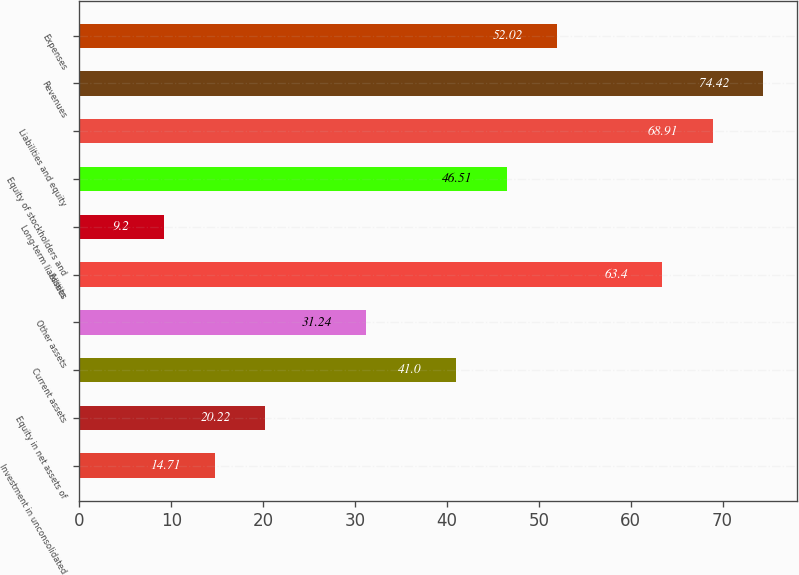Convert chart to OTSL. <chart><loc_0><loc_0><loc_500><loc_500><bar_chart><fcel>Investment in unconsolidated<fcel>Equity in net assets of<fcel>Current assets<fcel>Other assets<fcel>Assets<fcel>Long-term liabilities<fcel>Equity of stockholders and<fcel>Liabilities and equity<fcel>Revenues<fcel>Expenses<nl><fcel>14.71<fcel>20.22<fcel>41<fcel>31.24<fcel>63.4<fcel>9.2<fcel>46.51<fcel>68.91<fcel>74.42<fcel>52.02<nl></chart> 